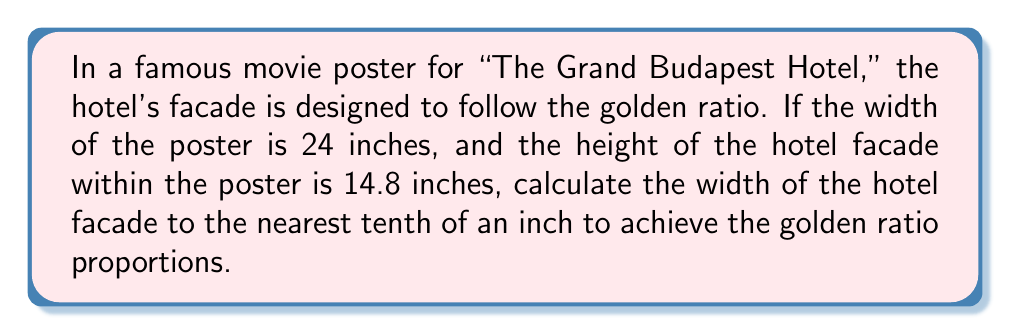Help me with this question. Let's approach this step-by-step:

1) The golden ratio, denoted by φ (phi), is approximately 1.618. It's defined by the equation:

   $$\frac{a+b}{a} = \frac{a}{b} = \phi \approx 1.618$$

   where $a$ is the longer segment and $b$ is the shorter segment.

2) In this case, the height of the hotel facade (14.8 inches) represents the shorter segment $b$.

3) Let $x$ be the width of the hotel facade (the longer segment $a$). We can set up the equation:

   $$\frac{x}{14.8} = 1.618$$

4) To solve for $x$, multiply both sides by 14.8:

   $$x = 14.8 * 1.618$$

5) Calculate:

   $$x = 23.9464$$

6) Rounding to the nearest tenth:

   $$x \approx 23.9 \text{ inches}$$

This width, combined with the given height of 14.8 inches, will create a rectangle that closely approximates the golden ratio proportions in the movie poster design.
Answer: 23.9 inches 